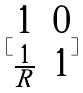<formula> <loc_0><loc_0><loc_500><loc_500>[ \begin{matrix} 1 & 0 \\ \frac { 1 } { R } & 1 \end{matrix} ]</formula> 